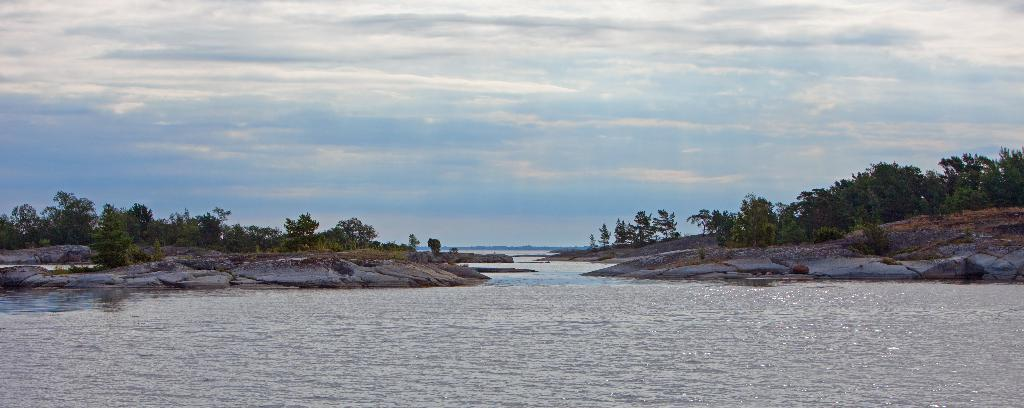What is the main feature of the image? The main feature of the image is water. What can be seen on either side of the water? There are rocks and trees on either side of the water. What is visible at the top of the image? The sky is visible at the top of the image. Can you see an airplane flying through the sky in the image? No, there is no airplane visible in the image. What type of soap is being used to clean the rocks in the image? There is no soap or cleaning activity depicted in the image; it only shows water, rocks, trees, and the sky. 